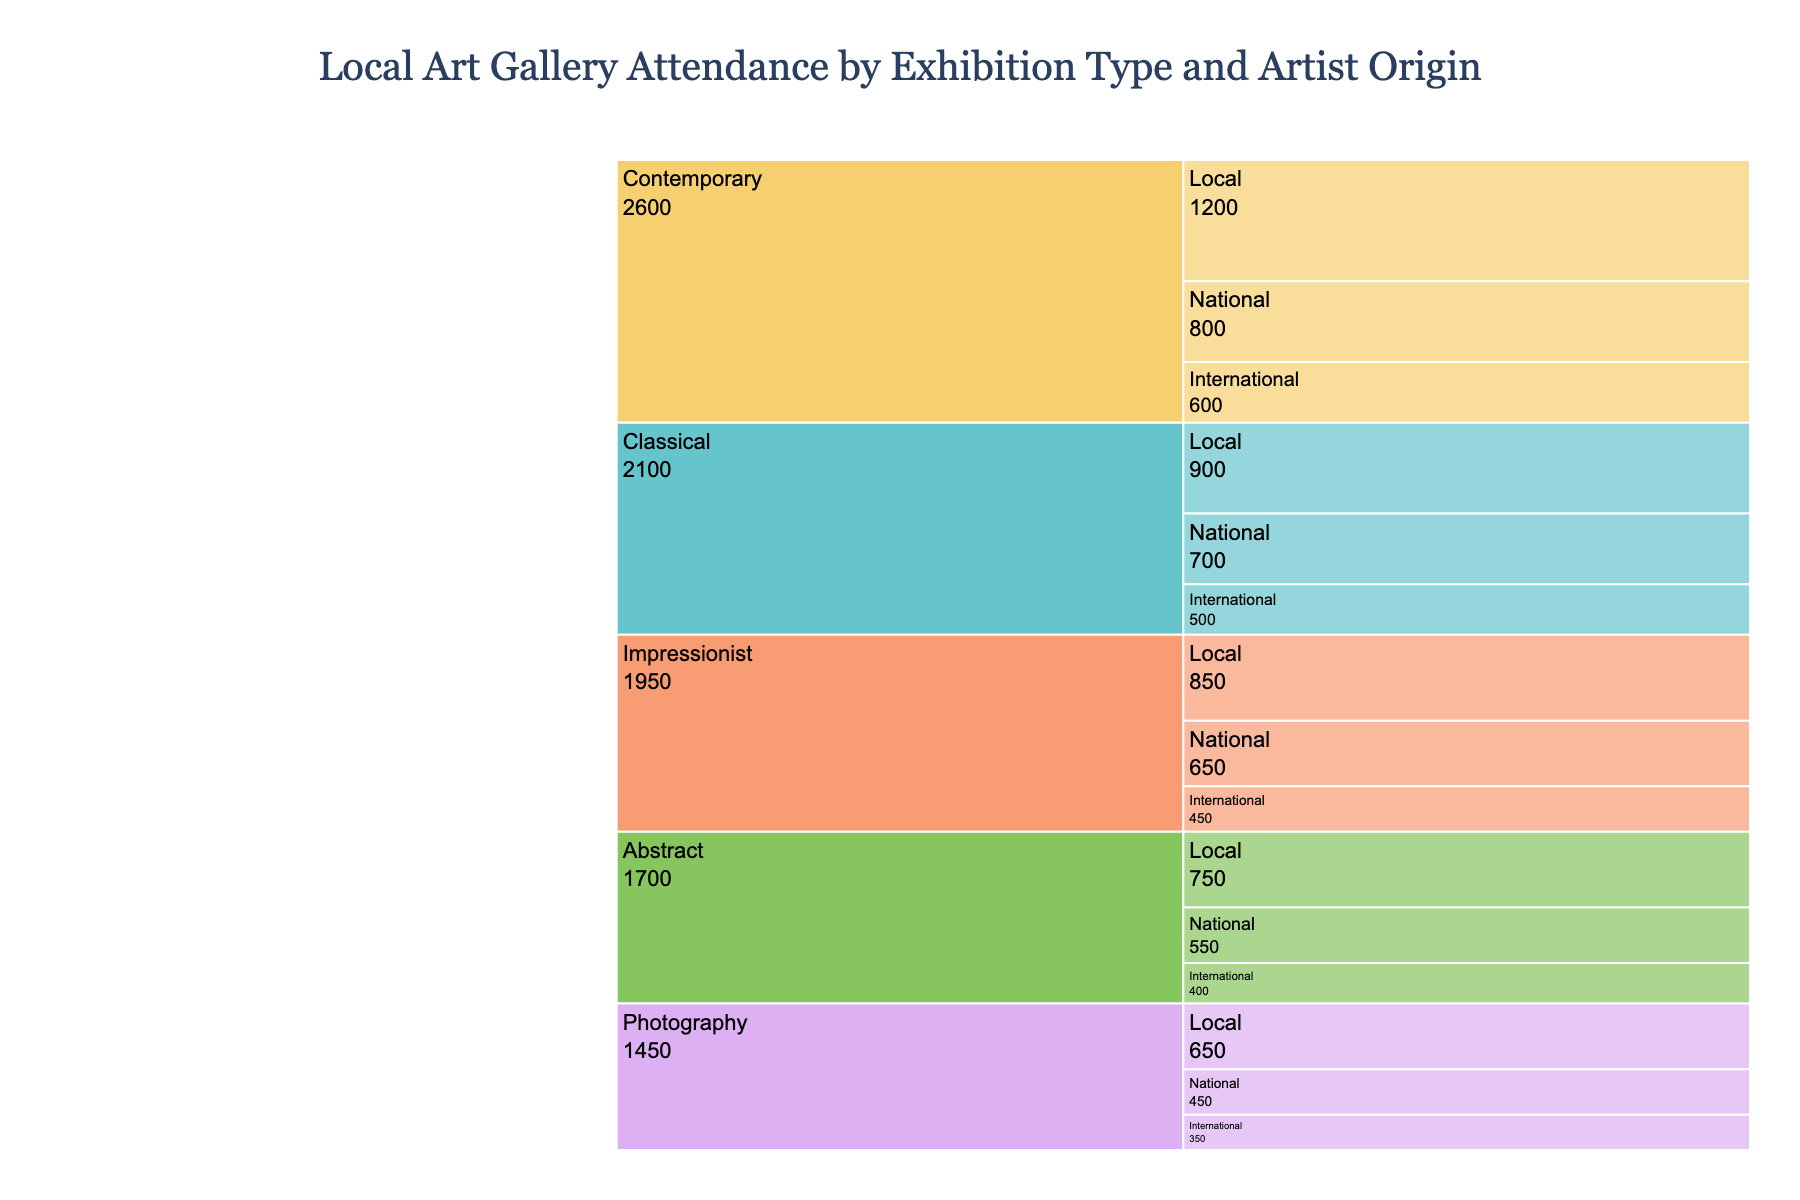What's the overall theme of the Icicle Chart? The title at the top of the Icicle Chart indicates the theme, which is "Local Art Gallery Attendance by Exhibition Type and Artist Origin." This tells us that the chart shows the attendance of different types of art exhibitions categorized by the origin of the artists.
Answer: Local Art Gallery Attendance by Exhibition Type and Artist Origin How many types of exhibitions are shown in the chart? By looking at the primary branches of the Icicle Chart, we can count the number of distinct exhibition types. These are the first categories branching out from the root.
Answer: 5 Which exhibition type has the highest local artist attendance? Identify the segment with the largest value (attendance) among the branches under "Local" for each exhibition type. Contemporary has 1200, Classical has 900, Abstract has 750, Impressionist has 850, and Photography has 650.
Answer: Contemporary What is the total attendance for Classical exhibitions? Sum the attendance values for Classical exhibitions across all artist origins: Local (900) + National (700) + International (500).
Answer: 2100 Compare the attendance of National artists in Contemporary and Abstract exhibitions. Which has more? Check the values for National artists within the Contemporary and Abstract segments. Contemporary has 800 (National) and Abstract has 550 (National).
Answer: Contemporary Which artist origin consistently has the lowest attendance across all exhibition types? Identify the smallest value in each exhibition type segment for Local, National, and International origins and see which origin appears most frequently.
Answer: International What is the combined attendance for all International artists? Sum the attendance values for International artists across all exhibition types: Contemporary (600) + Classical (500) + Abstract (400) + Impressionist (450) + Photography (350).
Answer: 2300 How does the attendance for Photography by Local artists compare to Abstract by Local artists? Look for the attendance values for Local artists in Photography (650) and Abstract (750) segments.
Answer: Abstract has more What percentage of the total attendance does the Impressionist, National artist segment represent? Determine the total attendance first by summing up all segments. Sum up (1200 + 800 + 600 + 900 + 700 + 500 + 750 + 550 + 400 + 850 + 650 + 450 + 650 + 450 + 350) = 10300. Then find the percentage for the Impressionist, National segment (650 / 10300) * 100% ≈ 6.31%.
Answer: 6.31% What is the largest segment in terms of attendance in the entire chart? Look for the segment with the highest attendance value across all categories. The highest value seen is 1200 under Contemporary, Local.
Answer: Contemporary, Local 